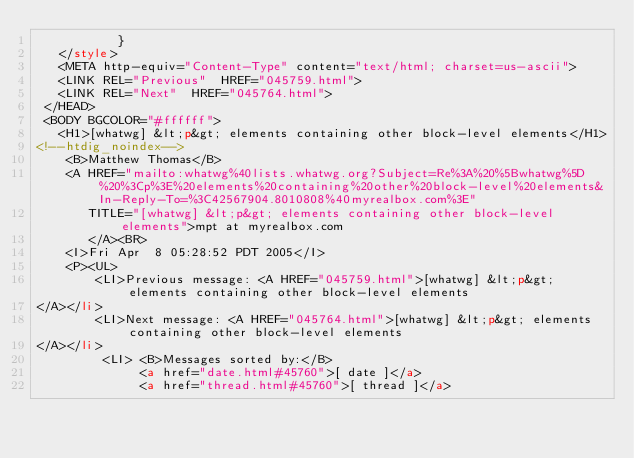<code> <loc_0><loc_0><loc_500><loc_500><_HTML_>           }
   </style>
   <META http-equiv="Content-Type" content="text/html; charset=us-ascii">
   <LINK REL="Previous"  HREF="045759.html">
   <LINK REL="Next"  HREF="045764.html">
 </HEAD>
 <BODY BGCOLOR="#ffffff">
   <H1>[whatwg] &lt;p&gt; elements containing other block-level elements</H1>
<!--htdig_noindex-->
    <B>Matthew Thomas</B> 
    <A HREF="mailto:whatwg%40lists.whatwg.org?Subject=Re%3A%20%5Bwhatwg%5D%20%3Cp%3E%20elements%20containing%20other%20block-level%20elements&In-Reply-To=%3C42567904.8010808%40myrealbox.com%3E"
       TITLE="[whatwg] &lt;p&gt; elements containing other block-level elements">mpt at myrealbox.com
       </A><BR>
    <I>Fri Apr  8 05:28:52 PDT 2005</I>
    <P><UL>
        <LI>Previous message: <A HREF="045759.html">[whatwg] &lt;p&gt; elements containing other block-level elements
</A></li>
        <LI>Next message: <A HREF="045764.html">[whatwg] &lt;p&gt; elements containing other block-level elements
</A></li>
         <LI> <B>Messages sorted by:</B> 
              <a href="date.html#45760">[ date ]</a>
              <a href="thread.html#45760">[ thread ]</a></code> 